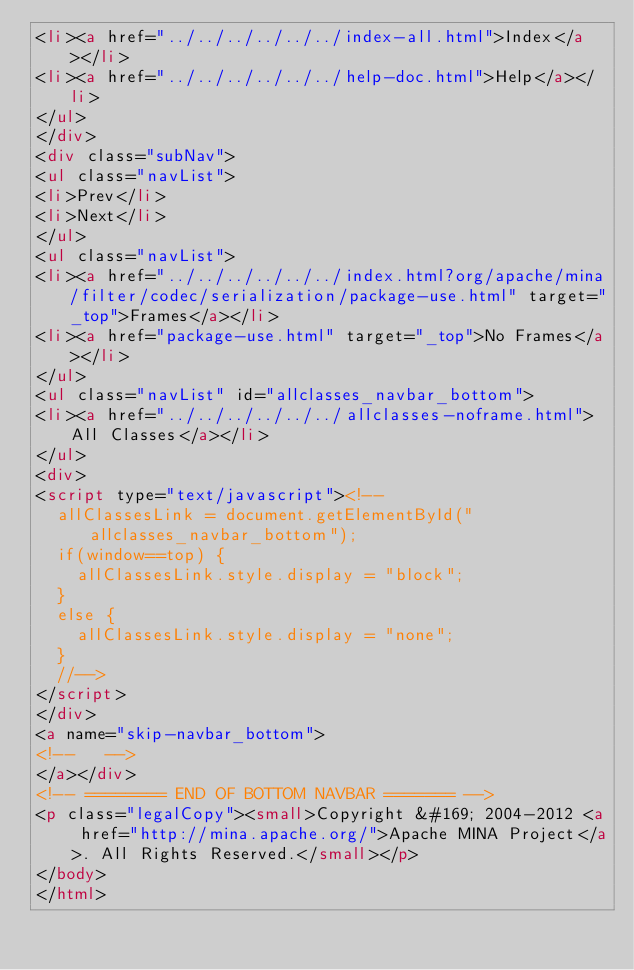<code> <loc_0><loc_0><loc_500><loc_500><_HTML_><li><a href="../../../../../../index-all.html">Index</a></li>
<li><a href="../../../../../../help-doc.html">Help</a></li>
</ul>
</div>
<div class="subNav">
<ul class="navList">
<li>Prev</li>
<li>Next</li>
</ul>
<ul class="navList">
<li><a href="../../../../../../index.html?org/apache/mina/filter/codec/serialization/package-use.html" target="_top">Frames</a></li>
<li><a href="package-use.html" target="_top">No Frames</a></li>
</ul>
<ul class="navList" id="allclasses_navbar_bottom">
<li><a href="../../../../../../allclasses-noframe.html">All Classes</a></li>
</ul>
<div>
<script type="text/javascript"><!--
  allClassesLink = document.getElementById("allclasses_navbar_bottom");
  if(window==top) {
    allClassesLink.style.display = "block";
  }
  else {
    allClassesLink.style.display = "none";
  }
  //-->
</script>
</div>
<a name="skip-navbar_bottom">
<!--   -->
</a></div>
<!-- ======== END OF BOTTOM NAVBAR ======= -->
<p class="legalCopy"><small>Copyright &#169; 2004-2012 <a href="http://mina.apache.org/">Apache MINA Project</a>. All Rights Reserved.</small></p>
</body>
</html>
</code> 